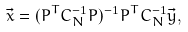Convert formula to latex. <formula><loc_0><loc_0><loc_500><loc_500>\vec { x } = ( P ^ { T } C _ { N } ^ { - 1 } P ) ^ { - 1 } P ^ { T } C _ { N } ^ { - 1 } \vec { y } ,</formula> 